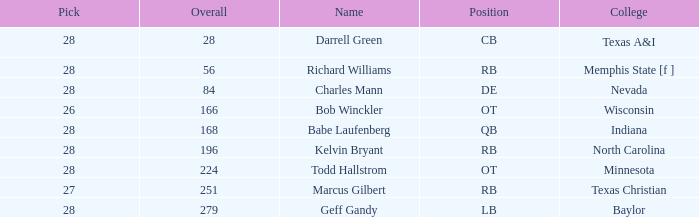What is the average round of the player from the college of baylor with a pick less than 28? None. 